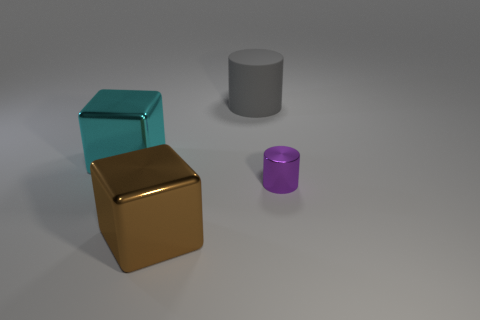Subtract 1 cylinders. How many cylinders are left? 1 Subtract all cyan blocks. How many blocks are left? 1 Add 1 big brown metal things. How many big brown metal things are left? 2 Add 1 tiny objects. How many tiny objects exist? 2 Add 2 tiny purple objects. How many objects exist? 6 Subtract 0 cyan cylinders. How many objects are left? 4 Subtract all purple cylinders. Subtract all blue balls. How many cylinders are left? 1 Subtract all blue cubes. How many gray cylinders are left? 1 Subtract all large yellow rubber balls. Subtract all purple things. How many objects are left? 3 